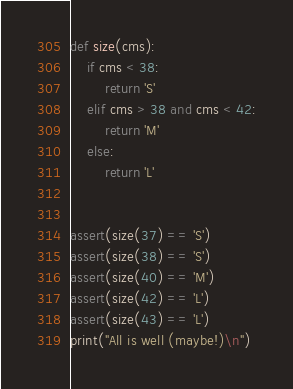Convert code to text. <code><loc_0><loc_0><loc_500><loc_500><_Python_>
def size(cms):
    if cms < 38:
        return 'S'
    elif cms > 38 and cms < 42:
        return 'M'
    else:
        return 'L'


assert(size(37) == 'S')
assert(size(38) == 'S')
assert(size(40) == 'M')
assert(size(42) == 'L')
assert(size(43) == 'L')
print("All is well (maybe!)\n")
</code> 